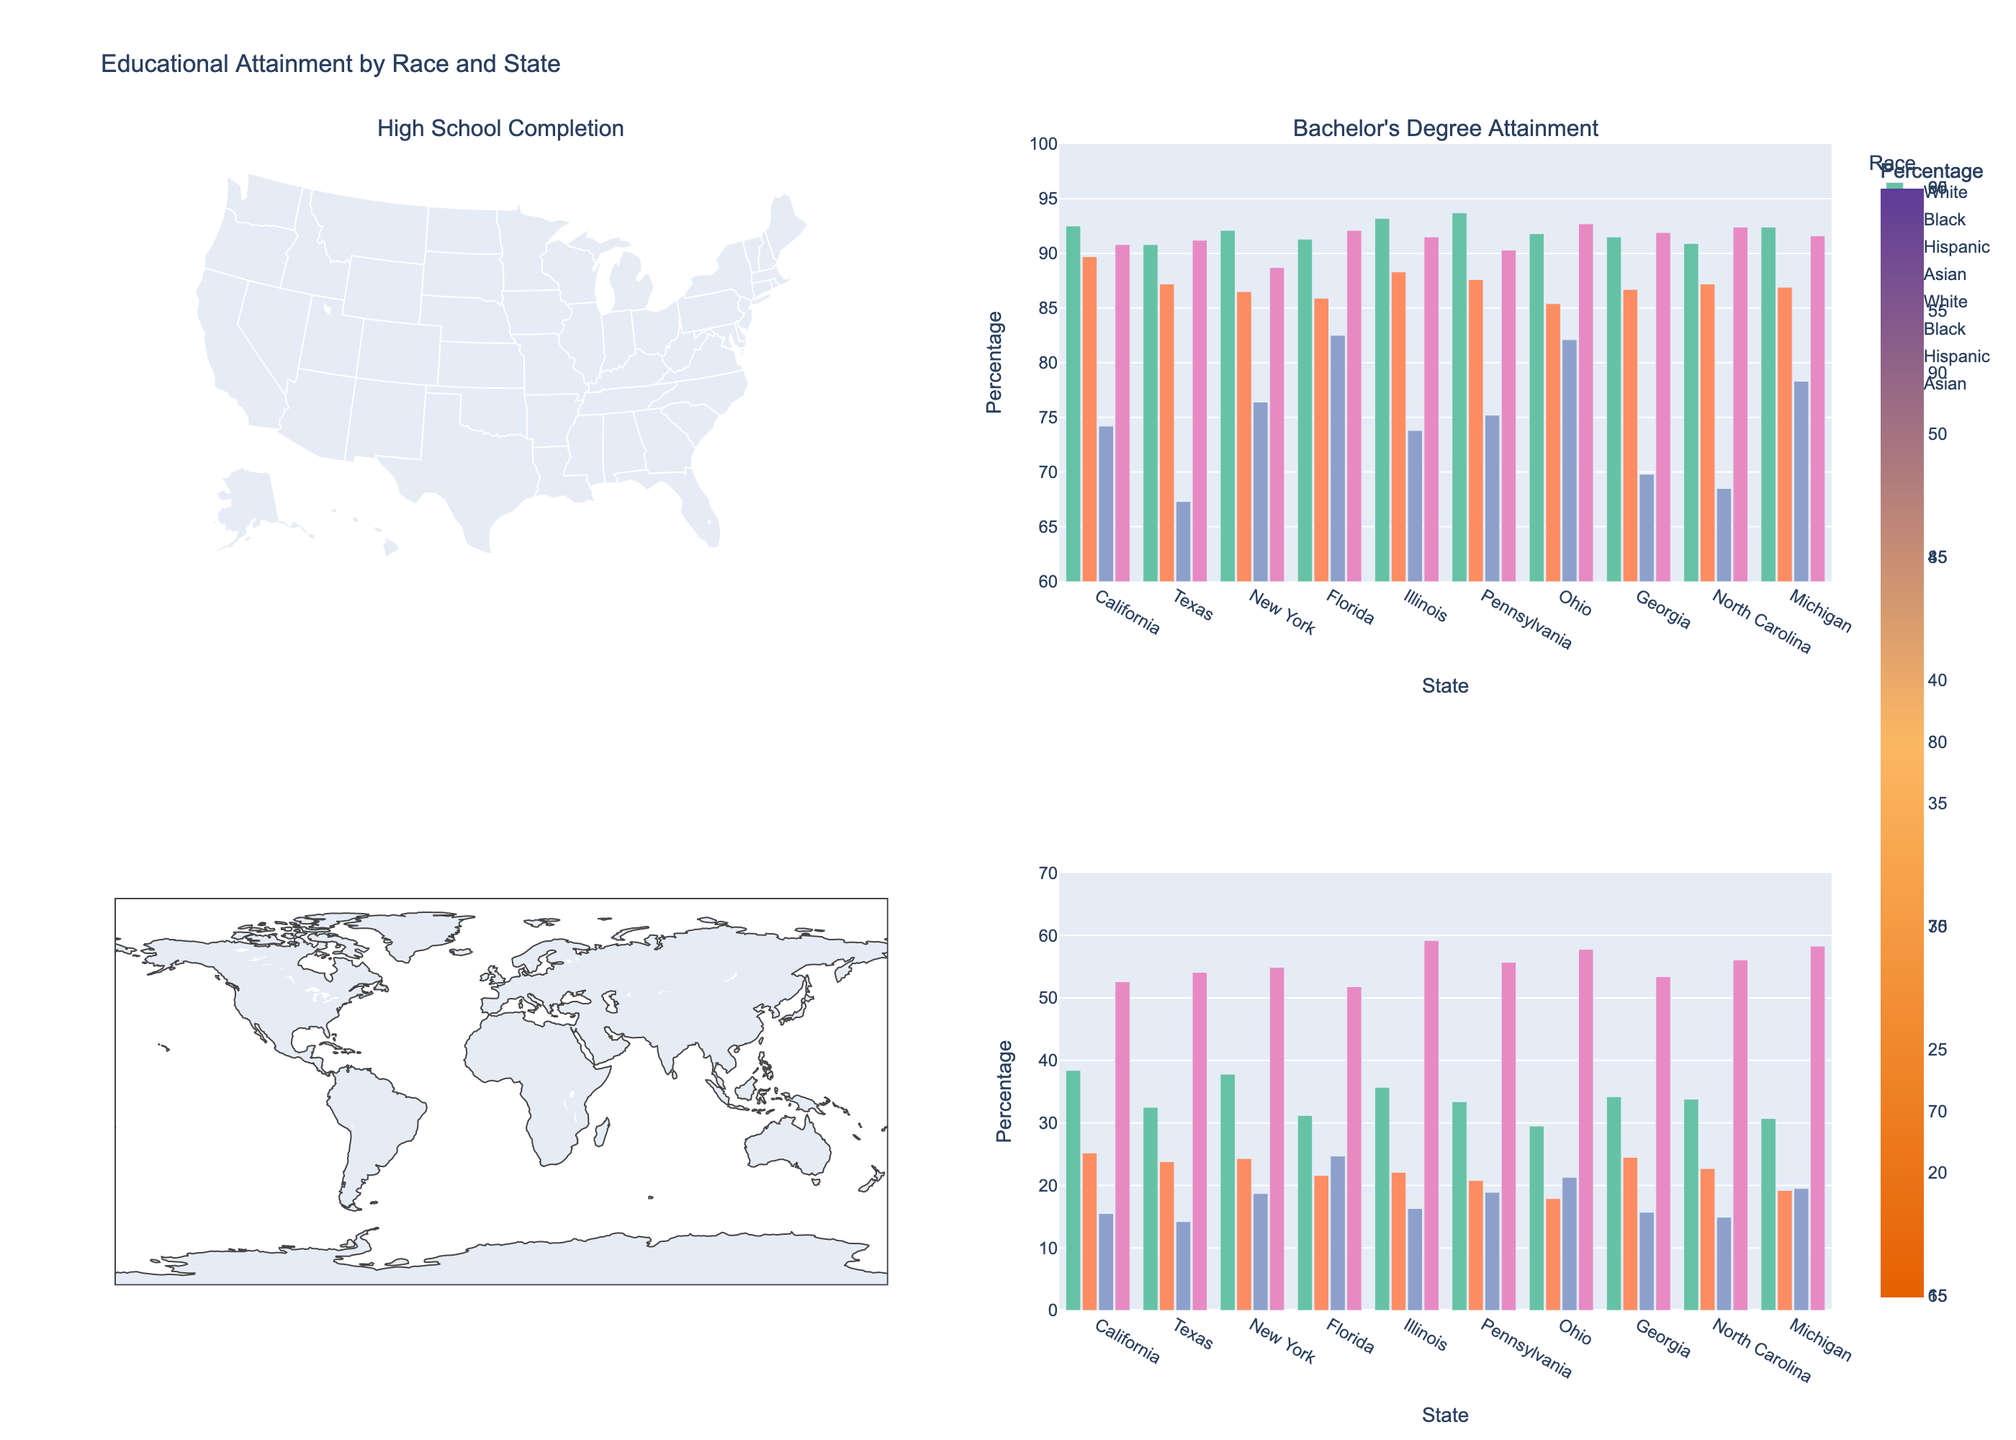How is the title of the plot phrased? The title is located at the top center of the plot. It reads "Educational Attainment by Race and State."
Answer: Educational Attainment by Race and State What are the color scales used for high school completion and bachelor's degree attainment? The high school completion choropleth uses a colorscale transitioning from shades of red to blue, while the bachelor's degree attainment choropleth uses shades transitioning from orange to purple.
Answer: shades of red to blue, shades of orange to purple Which state has the lowest high school completion rate for Hispanics? In the bar chart for high school completion, look for the lowest bar among the Hispanic group. Texas has the lowest value at 67.3%.
Answer: Texas Compare the bachelor's degree attainment rates for Asians in California and New York. Which state has a higher rate, and by how much? In the bar chart for bachelor's degree attainment, find the height of the bars for Asians in both California and New York. California's rate is 52.6%, and New York's is 54.9%. New York has a higher rate. The difference is calculated as 54.9% - 52.6% = 2.3%.
Answer: New York, 2.3% What is the range of high school completion rates for Whites across all states? Look at the high school completion bar chart and identify the highest and lowest values for Whites. The maximum rate is 93.7% (Pennsylvania) and the minimum rate is 90.8% (Texas). The range is calculated as 93.7% - 90.8% = 2.9%.
Answer: 2.9% In which state do Blacks have a higher bachelor's degree attainment rate compared to Hispanics, and by how much? Look at the bar chart for bachelor's degree attainment and compare the heights of the bars for Blacks and Hispanics in each state. In Florida, Blacks have a rate of 21.6% and Hispanics have a rate of 24.7%. Hispanics always have higher rates than Blacks in all other states. The difference in Florida is 24.7% - 21.6% = -3.1%.
Answer: None Which state has the highest high school completion rate for Asians? In the bar chart for high school completion, identify the tallest bar among the Asian group. Ohio has the highest rate at 92.7%.
Answer: Ohio 